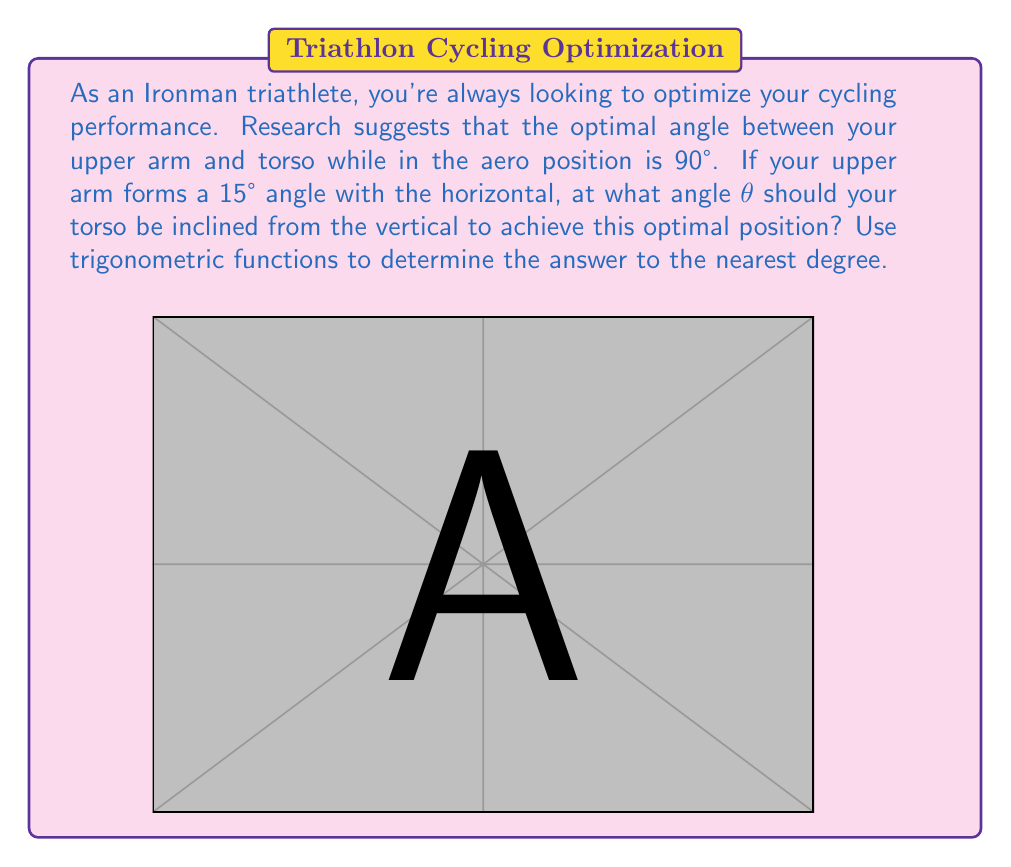What is the answer to this math problem? Let's approach this step-by-step using trigonometric functions:

1) First, we need to recognize that the angle we're looking for (θ) plus the 15° angle of the upper arm, plus the 90° optimal angle should add up to 180° (a straight line).

   $$\theta + 15° + 90° = 180°$$

2) We can solve this equation for θ:

   $$\theta = 180° - 15° - 90° = 75°$$

3) However, we need to verify this using trigonometric functions. Let's consider the right triangle formed by the torso, the vertical, and the horizontal line to the end of the upper arm.

4) In this triangle, we know:
   - The angle between the upper arm and the horizontal is 15°
   - The angle we're looking for (θ) is the complement of this angle to 90°

5) We can express this relationship using the tangent function:

   $$\tan(90° - \theta) = \tan(15°)$$

6) Using the tangent of complementary angles identity:

   $$\cot(\theta) = \tan(15°)$$

7) Taking the inverse cotangent (arccotangent) of both sides:

   $$\theta = \arctan(\frac{1}{\tan(15°)})$$

8) Using a calculator or computer:

   $$\theta \approx 75.00°$$

9) Rounding to the nearest degree as requested:

   $$\theta = 75°$$

This confirms our initial calculation.
Answer: 75° 